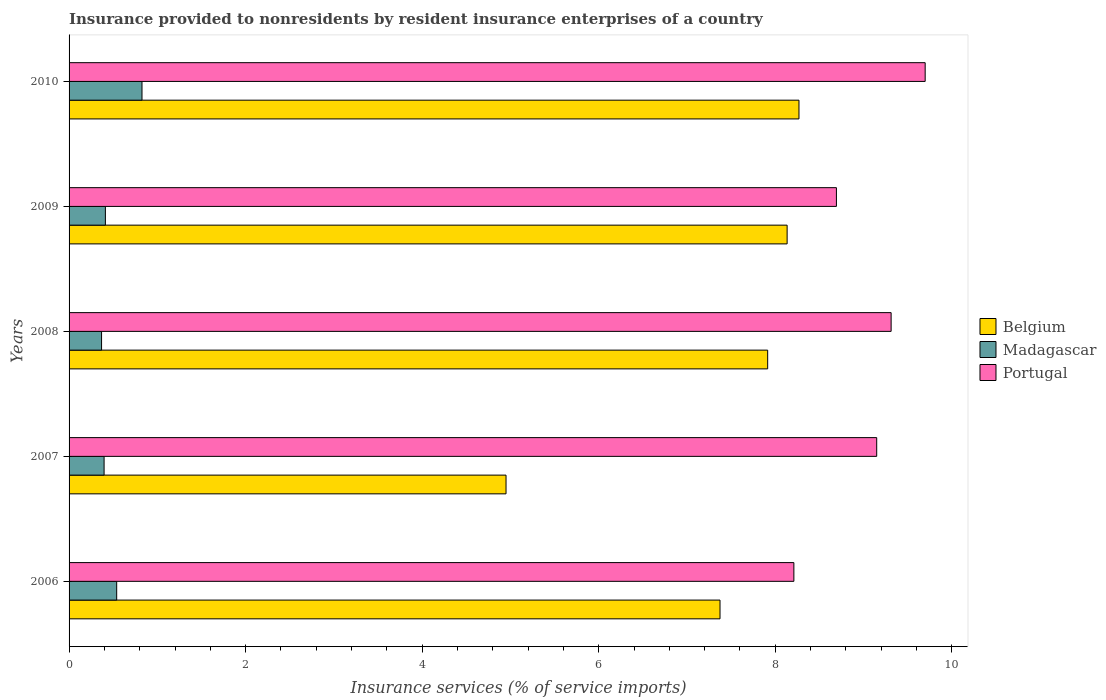How many different coloured bars are there?
Offer a terse response. 3. How many groups of bars are there?
Make the answer very short. 5. How many bars are there on the 1st tick from the top?
Your answer should be very brief. 3. How many bars are there on the 1st tick from the bottom?
Offer a terse response. 3. What is the label of the 3rd group of bars from the top?
Give a very brief answer. 2008. In how many cases, is the number of bars for a given year not equal to the number of legend labels?
Ensure brevity in your answer.  0. What is the insurance provided to nonresidents in Belgium in 2006?
Keep it short and to the point. 7.37. Across all years, what is the maximum insurance provided to nonresidents in Belgium?
Give a very brief answer. 8.27. Across all years, what is the minimum insurance provided to nonresidents in Madagascar?
Make the answer very short. 0.37. What is the total insurance provided to nonresidents in Belgium in the graph?
Keep it short and to the point. 36.64. What is the difference between the insurance provided to nonresidents in Portugal in 2006 and that in 2008?
Your answer should be very brief. -1.1. What is the difference between the insurance provided to nonresidents in Belgium in 2008 and the insurance provided to nonresidents in Portugal in 2007?
Your answer should be very brief. -1.24. What is the average insurance provided to nonresidents in Belgium per year?
Make the answer very short. 7.33. In the year 2008, what is the difference between the insurance provided to nonresidents in Belgium and insurance provided to nonresidents in Portugal?
Your answer should be compact. -1.4. In how many years, is the insurance provided to nonresidents in Madagascar greater than 1.6 %?
Provide a succinct answer. 0. What is the ratio of the insurance provided to nonresidents in Belgium in 2007 to that in 2010?
Offer a terse response. 0.6. Is the insurance provided to nonresidents in Belgium in 2006 less than that in 2010?
Provide a short and direct response. Yes. What is the difference between the highest and the second highest insurance provided to nonresidents in Belgium?
Provide a succinct answer. 0.13. What is the difference between the highest and the lowest insurance provided to nonresidents in Portugal?
Your response must be concise. 1.49. In how many years, is the insurance provided to nonresidents in Madagascar greater than the average insurance provided to nonresidents in Madagascar taken over all years?
Keep it short and to the point. 2. What does the 1st bar from the top in 2006 represents?
Keep it short and to the point. Portugal. Is it the case that in every year, the sum of the insurance provided to nonresidents in Madagascar and insurance provided to nonresidents in Portugal is greater than the insurance provided to nonresidents in Belgium?
Provide a short and direct response. Yes. Are all the bars in the graph horizontal?
Give a very brief answer. Yes. Does the graph contain any zero values?
Offer a terse response. No. Does the graph contain grids?
Ensure brevity in your answer.  No. How are the legend labels stacked?
Offer a terse response. Vertical. What is the title of the graph?
Offer a very short reply. Insurance provided to nonresidents by resident insurance enterprises of a country. What is the label or title of the X-axis?
Offer a terse response. Insurance services (% of service imports). What is the label or title of the Y-axis?
Offer a very short reply. Years. What is the Insurance services (% of service imports) in Belgium in 2006?
Offer a terse response. 7.37. What is the Insurance services (% of service imports) in Madagascar in 2006?
Your answer should be compact. 0.54. What is the Insurance services (% of service imports) of Portugal in 2006?
Provide a succinct answer. 8.21. What is the Insurance services (% of service imports) in Belgium in 2007?
Your answer should be compact. 4.95. What is the Insurance services (% of service imports) in Madagascar in 2007?
Your response must be concise. 0.4. What is the Insurance services (% of service imports) in Portugal in 2007?
Your answer should be very brief. 9.15. What is the Insurance services (% of service imports) of Belgium in 2008?
Your response must be concise. 7.91. What is the Insurance services (% of service imports) in Madagascar in 2008?
Offer a terse response. 0.37. What is the Insurance services (% of service imports) in Portugal in 2008?
Your answer should be compact. 9.31. What is the Insurance services (% of service imports) in Belgium in 2009?
Your answer should be very brief. 8.13. What is the Insurance services (% of service imports) of Madagascar in 2009?
Ensure brevity in your answer.  0.41. What is the Insurance services (% of service imports) of Portugal in 2009?
Provide a short and direct response. 8.69. What is the Insurance services (% of service imports) in Belgium in 2010?
Your answer should be compact. 8.27. What is the Insurance services (% of service imports) of Madagascar in 2010?
Offer a very short reply. 0.83. What is the Insurance services (% of service imports) of Portugal in 2010?
Give a very brief answer. 9.7. Across all years, what is the maximum Insurance services (% of service imports) in Belgium?
Provide a succinct answer. 8.27. Across all years, what is the maximum Insurance services (% of service imports) of Madagascar?
Offer a very short reply. 0.83. Across all years, what is the maximum Insurance services (% of service imports) in Portugal?
Give a very brief answer. 9.7. Across all years, what is the minimum Insurance services (% of service imports) of Belgium?
Provide a short and direct response. 4.95. Across all years, what is the minimum Insurance services (% of service imports) of Madagascar?
Give a very brief answer. 0.37. Across all years, what is the minimum Insurance services (% of service imports) in Portugal?
Ensure brevity in your answer.  8.21. What is the total Insurance services (% of service imports) of Belgium in the graph?
Your answer should be very brief. 36.64. What is the total Insurance services (% of service imports) in Madagascar in the graph?
Ensure brevity in your answer.  2.54. What is the total Insurance services (% of service imports) of Portugal in the graph?
Provide a short and direct response. 45.07. What is the difference between the Insurance services (% of service imports) of Belgium in 2006 and that in 2007?
Make the answer very short. 2.42. What is the difference between the Insurance services (% of service imports) in Madagascar in 2006 and that in 2007?
Ensure brevity in your answer.  0.14. What is the difference between the Insurance services (% of service imports) in Portugal in 2006 and that in 2007?
Your answer should be compact. -0.94. What is the difference between the Insurance services (% of service imports) of Belgium in 2006 and that in 2008?
Your answer should be compact. -0.54. What is the difference between the Insurance services (% of service imports) in Madagascar in 2006 and that in 2008?
Keep it short and to the point. 0.17. What is the difference between the Insurance services (% of service imports) in Portugal in 2006 and that in 2008?
Make the answer very short. -1.1. What is the difference between the Insurance services (% of service imports) of Belgium in 2006 and that in 2009?
Your response must be concise. -0.76. What is the difference between the Insurance services (% of service imports) of Madagascar in 2006 and that in 2009?
Keep it short and to the point. 0.13. What is the difference between the Insurance services (% of service imports) of Portugal in 2006 and that in 2009?
Offer a terse response. -0.48. What is the difference between the Insurance services (% of service imports) in Belgium in 2006 and that in 2010?
Keep it short and to the point. -0.89. What is the difference between the Insurance services (% of service imports) of Madagascar in 2006 and that in 2010?
Your answer should be very brief. -0.29. What is the difference between the Insurance services (% of service imports) of Portugal in 2006 and that in 2010?
Offer a very short reply. -1.49. What is the difference between the Insurance services (% of service imports) in Belgium in 2007 and that in 2008?
Provide a short and direct response. -2.96. What is the difference between the Insurance services (% of service imports) in Madagascar in 2007 and that in 2008?
Give a very brief answer. 0.03. What is the difference between the Insurance services (% of service imports) in Portugal in 2007 and that in 2008?
Provide a succinct answer. -0.16. What is the difference between the Insurance services (% of service imports) in Belgium in 2007 and that in 2009?
Provide a short and direct response. -3.18. What is the difference between the Insurance services (% of service imports) of Madagascar in 2007 and that in 2009?
Your answer should be very brief. -0.01. What is the difference between the Insurance services (% of service imports) of Portugal in 2007 and that in 2009?
Your answer should be compact. 0.46. What is the difference between the Insurance services (% of service imports) of Belgium in 2007 and that in 2010?
Your answer should be very brief. -3.32. What is the difference between the Insurance services (% of service imports) in Madagascar in 2007 and that in 2010?
Provide a succinct answer. -0.43. What is the difference between the Insurance services (% of service imports) in Portugal in 2007 and that in 2010?
Offer a very short reply. -0.55. What is the difference between the Insurance services (% of service imports) of Belgium in 2008 and that in 2009?
Your answer should be compact. -0.22. What is the difference between the Insurance services (% of service imports) of Madagascar in 2008 and that in 2009?
Ensure brevity in your answer.  -0.04. What is the difference between the Insurance services (% of service imports) of Portugal in 2008 and that in 2009?
Offer a terse response. 0.62. What is the difference between the Insurance services (% of service imports) in Belgium in 2008 and that in 2010?
Give a very brief answer. -0.35. What is the difference between the Insurance services (% of service imports) in Madagascar in 2008 and that in 2010?
Make the answer very short. -0.46. What is the difference between the Insurance services (% of service imports) of Portugal in 2008 and that in 2010?
Offer a very short reply. -0.39. What is the difference between the Insurance services (% of service imports) in Belgium in 2009 and that in 2010?
Your answer should be compact. -0.13. What is the difference between the Insurance services (% of service imports) in Madagascar in 2009 and that in 2010?
Keep it short and to the point. -0.41. What is the difference between the Insurance services (% of service imports) in Portugal in 2009 and that in 2010?
Offer a terse response. -1.01. What is the difference between the Insurance services (% of service imports) of Belgium in 2006 and the Insurance services (% of service imports) of Madagascar in 2007?
Your response must be concise. 6.98. What is the difference between the Insurance services (% of service imports) in Belgium in 2006 and the Insurance services (% of service imports) in Portugal in 2007?
Your answer should be very brief. -1.78. What is the difference between the Insurance services (% of service imports) in Madagascar in 2006 and the Insurance services (% of service imports) in Portugal in 2007?
Keep it short and to the point. -8.61. What is the difference between the Insurance services (% of service imports) of Belgium in 2006 and the Insurance services (% of service imports) of Madagascar in 2008?
Provide a succinct answer. 7.01. What is the difference between the Insurance services (% of service imports) in Belgium in 2006 and the Insurance services (% of service imports) in Portugal in 2008?
Your response must be concise. -1.94. What is the difference between the Insurance services (% of service imports) of Madagascar in 2006 and the Insurance services (% of service imports) of Portugal in 2008?
Your answer should be very brief. -8.77. What is the difference between the Insurance services (% of service imports) of Belgium in 2006 and the Insurance services (% of service imports) of Madagascar in 2009?
Your answer should be compact. 6.96. What is the difference between the Insurance services (% of service imports) in Belgium in 2006 and the Insurance services (% of service imports) in Portugal in 2009?
Your response must be concise. -1.32. What is the difference between the Insurance services (% of service imports) in Madagascar in 2006 and the Insurance services (% of service imports) in Portugal in 2009?
Give a very brief answer. -8.15. What is the difference between the Insurance services (% of service imports) of Belgium in 2006 and the Insurance services (% of service imports) of Madagascar in 2010?
Offer a terse response. 6.55. What is the difference between the Insurance services (% of service imports) in Belgium in 2006 and the Insurance services (% of service imports) in Portugal in 2010?
Offer a very short reply. -2.32. What is the difference between the Insurance services (% of service imports) in Madagascar in 2006 and the Insurance services (% of service imports) in Portugal in 2010?
Ensure brevity in your answer.  -9.16. What is the difference between the Insurance services (% of service imports) of Belgium in 2007 and the Insurance services (% of service imports) of Madagascar in 2008?
Provide a succinct answer. 4.58. What is the difference between the Insurance services (% of service imports) in Belgium in 2007 and the Insurance services (% of service imports) in Portugal in 2008?
Give a very brief answer. -4.36. What is the difference between the Insurance services (% of service imports) of Madagascar in 2007 and the Insurance services (% of service imports) of Portugal in 2008?
Offer a very short reply. -8.92. What is the difference between the Insurance services (% of service imports) in Belgium in 2007 and the Insurance services (% of service imports) in Madagascar in 2009?
Your answer should be very brief. 4.54. What is the difference between the Insurance services (% of service imports) in Belgium in 2007 and the Insurance services (% of service imports) in Portugal in 2009?
Offer a very short reply. -3.74. What is the difference between the Insurance services (% of service imports) in Madagascar in 2007 and the Insurance services (% of service imports) in Portugal in 2009?
Make the answer very short. -8.3. What is the difference between the Insurance services (% of service imports) in Belgium in 2007 and the Insurance services (% of service imports) in Madagascar in 2010?
Provide a short and direct response. 4.12. What is the difference between the Insurance services (% of service imports) of Belgium in 2007 and the Insurance services (% of service imports) of Portugal in 2010?
Your response must be concise. -4.75. What is the difference between the Insurance services (% of service imports) in Madagascar in 2007 and the Insurance services (% of service imports) in Portugal in 2010?
Ensure brevity in your answer.  -9.3. What is the difference between the Insurance services (% of service imports) in Belgium in 2008 and the Insurance services (% of service imports) in Madagascar in 2009?
Offer a terse response. 7.5. What is the difference between the Insurance services (% of service imports) in Belgium in 2008 and the Insurance services (% of service imports) in Portugal in 2009?
Give a very brief answer. -0.78. What is the difference between the Insurance services (% of service imports) of Madagascar in 2008 and the Insurance services (% of service imports) of Portugal in 2009?
Offer a very short reply. -8.33. What is the difference between the Insurance services (% of service imports) of Belgium in 2008 and the Insurance services (% of service imports) of Madagascar in 2010?
Your answer should be compact. 7.09. What is the difference between the Insurance services (% of service imports) of Belgium in 2008 and the Insurance services (% of service imports) of Portugal in 2010?
Give a very brief answer. -1.78. What is the difference between the Insurance services (% of service imports) in Madagascar in 2008 and the Insurance services (% of service imports) in Portugal in 2010?
Give a very brief answer. -9.33. What is the difference between the Insurance services (% of service imports) of Belgium in 2009 and the Insurance services (% of service imports) of Madagascar in 2010?
Provide a succinct answer. 7.31. What is the difference between the Insurance services (% of service imports) of Belgium in 2009 and the Insurance services (% of service imports) of Portugal in 2010?
Ensure brevity in your answer.  -1.56. What is the difference between the Insurance services (% of service imports) of Madagascar in 2009 and the Insurance services (% of service imports) of Portugal in 2010?
Your answer should be very brief. -9.29. What is the average Insurance services (% of service imports) in Belgium per year?
Provide a succinct answer. 7.33. What is the average Insurance services (% of service imports) of Madagascar per year?
Keep it short and to the point. 0.51. What is the average Insurance services (% of service imports) of Portugal per year?
Give a very brief answer. 9.01. In the year 2006, what is the difference between the Insurance services (% of service imports) in Belgium and Insurance services (% of service imports) in Madagascar?
Your answer should be compact. 6.83. In the year 2006, what is the difference between the Insurance services (% of service imports) in Belgium and Insurance services (% of service imports) in Portugal?
Provide a succinct answer. -0.84. In the year 2006, what is the difference between the Insurance services (% of service imports) in Madagascar and Insurance services (% of service imports) in Portugal?
Ensure brevity in your answer.  -7.67. In the year 2007, what is the difference between the Insurance services (% of service imports) in Belgium and Insurance services (% of service imports) in Madagascar?
Give a very brief answer. 4.55. In the year 2007, what is the difference between the Insurance services (% of service imports) of Belgium and Insurance services (% of service imports) of Portugal?
Your response must be concise. -4.2. In the year 2007, what is the difference between the Insurance services (% of service imports) of Madagascar and Insurance services (% of service imports) of Portugal?
Give a very brief answer. -8.75. In the year 2008, what is the difference between the Insurance services (% of service imports) in Belgium and Insurance services (% of service imports) in Madagascar?
Your answer should be very brief. 7.55. In the year 2008, what is the difference between the Insurance services (% of service imports) of Belgium and Insurance services (% of service imports) of Portugal?
Provide a short and direct response. -1.4. In the year 2008, what is the difference between the Insurance services (% of service imports) of Madagascar and Insurance services (% of service imports) of Portugal?
Provide a succinct answer. -8.94. In the year 2009, what is the difference between the Insurance services (% of service imports) in Belgium and Insurance services (% of service imports) in Madagascar?
Provide a short and direct response. 7.72. In the year 2009, what is the difference between the Insurance services (% of service imports) of Belgium and Insurance services (% of service imports) of Portugal?
Provide a succinct answer. -0.56. In the year 2009, what is the difference between the Insurance services (% of service imports) of Madagascar and Insurance services (% of service imports) of Portugal?
Your answer should be compact. -8.28. In the year 2010, what is the difference between the Insurance services (% of service imports) in Belgium and Insurance services (% of service imports) in Madagascar?
Your answer should be compact. 7.44. In the year 2010, what is the difference between the Insurance services (% of service imports) in Belgium and Insurance services (% of service imports) in Portugal?
Ensure brevity in your answer.  -1.43. In the year 2010, what is the difference between the Insurance services (% of service imports) in Madagascar and Insurance services (% of service imports) in Portugal?
Make the answer very short. -8.87. What is the ratio of the Insurance services (% of service imports) in Belgium in 2006 to that in 2007?
Provide a short and direct response. 1.49. What is the ratio of the Insurance services (% of service imports) in Madagascar in 2006 to that in 2007?
Provide a short and direct response. 1.36. What is the ratio of the Insurance services (% of service imports) in Portugal in 2006 to that in 2007?
Make the answer very short. 0.9. What is the ratio of the Insurance services (% of service imports) in Belgium in 2006 to that in 2008?
Your response must be concise. 0.93. What is the ratio of the Insurance services (% of service imports) of Madagascar in 2006 to that in 2008?
Provide a short and direct response. 1.47. What is the ratio of the Insurance services (% of service imports) in Portugal in 2006 to that in 2008?
Keep it short and to the point. 0.88. What is the ratio of the Insurance services (% of service imports) in Belgium in 2006 to that in 2009?
Offer a terse response. 0.91. What is the ratio of the Insurance services (% of service imports) in Madagascar in 2006 to that in 2009?
Your answer should be compact. 1.31. What is the ratio of the Insurance services (% of service imports) of Portugal in 2006 to that in 2009?
Offer a very short reply. 0.94. What is the ratio of the Insurance services (% of service imports) in Belgium in 2006 to that in 2010?
Ensure brevity in your answer.  0.89. What is the ratio of the Insurance services (% of service imports) in Madagascar in 2006 to that in 2010?
Offer a terse response. 0.65. What is the ratio of the Insurance services (% of service imports) in Portugal in 2006 to that in 2010?
Your answer should be very brief. 0.85. What is the ratio of the Insurance services (% of service imports) in Belgium in 2007 to that in 2008?
Ensure brevity in your answer.  0.63. What is the ratio of the Insurance services (% of service imports) in Madagascar in 2007 to that in 2008?
Offer a terse response. 1.08. What is the ratio of the Insurance services (% of service imports) of Portugal in 2007 to that in 2008?
Your answer should be very brief. 0.98. What is the ratio of the Insurance services (% of service imports) of Belgium in 2007 to that in 2009?
Your answer should be very brief. 0.61. What is the ratio of the Insurance services (% of service imports) in Madagascar in 2007 to that in 2009?
Give a very brief answer. 0.96. What is the ratio of the Insurance services (% of service imports) in Portugal in 2007 to that in 2009?
Make the answer very short. 1.05. What is the ratio of the Insurance services (% of service imports) of Belgium in 2007 to that in 2010?
Your answer should be compact. 0.6. What is the ratio of the Insurance services (% of service imports) in Madagascar in 2007 to that in 2010?
Provide a short and direct response. 0.48. What is the ratio of the Insurance services (% of service imports) in Portugal in 2007 to that in 2010?
Provide a short and direct response. 0.94. What is the ratio of the Insurance services (% of service imports) of Belgium in 2008 to that in 2009?
Keep it short and to the point. 0.97. What is the ratio of the Insurance services (% of service imports) of Madagascar in 2008 to that in 2009?
Your answer should be compact. 0.89. What is the ratio of the Insurance services (% of service imports) of Portugal in 2008 to that in 2009?
Offer a terse response. 1.07. What is the ratio of the Insurance services (% of service imports) of Belgium in 2008 to that in 2010?
Provide a succinct answer. 0.96. What is the ratio of the Insurance services (% of service imports) of Madagascar in 2008 to that in 2010?
Offer a very short reply. 0.45. What is the ratio of the Insurance services (% of service imports) in Portugal in 2008 to that in 2010?
Your answer should be very brief. 0.96. What is the ratio of the Insurance services (% of service imports) in Belgium in 2009 to that in 2010?
Ensure brevity in your answer.  0.98. What is the ratio of the Insurance services (% of service imports) of Madagascar in 2009 to that in 2010?
Provide a succinct answer. 0.5. What is the ratio of the Insurance services (% of service imports) in Portugal in 2009 to that in 2010?
Your answer should be compact. 0.9. What is the difference between the highest and the second highest Insurance services (% of service imports) of Belgium?
Your answer should be compact. 0.13. What is the difference between the highest and the second highest Insurance services (% of service imports) in Madagascar?
Give a very brief answer. 0.29. What is the difference between the highest and the second highest Insurance services (% of service imports) of Portugal?
Offer a terse response. 0.39. What is the difference between the highest and the lowest Insurance services (% of service imports) in Belgium?
Provide a short and direct response. 3.32. What is the difference between the highest and the lowest Insurance services (% of service imports) of Madagascar?
Your response must be concise. 0.46. What is the difference between the highest and the lowest Insurance services (% of service imports) in Portugal?
Provide a succinct answer. 1.49. 